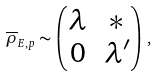Convert formula to latex. <formula><loc_0><loc_0><loc_500><loc_500>\overline { \rho } _ { E , p } \sim \begin{pmatrix} \lambda & * \\ 0 & \lambda ^ { \prime } \end{pmatrix} \, ,</formula> 